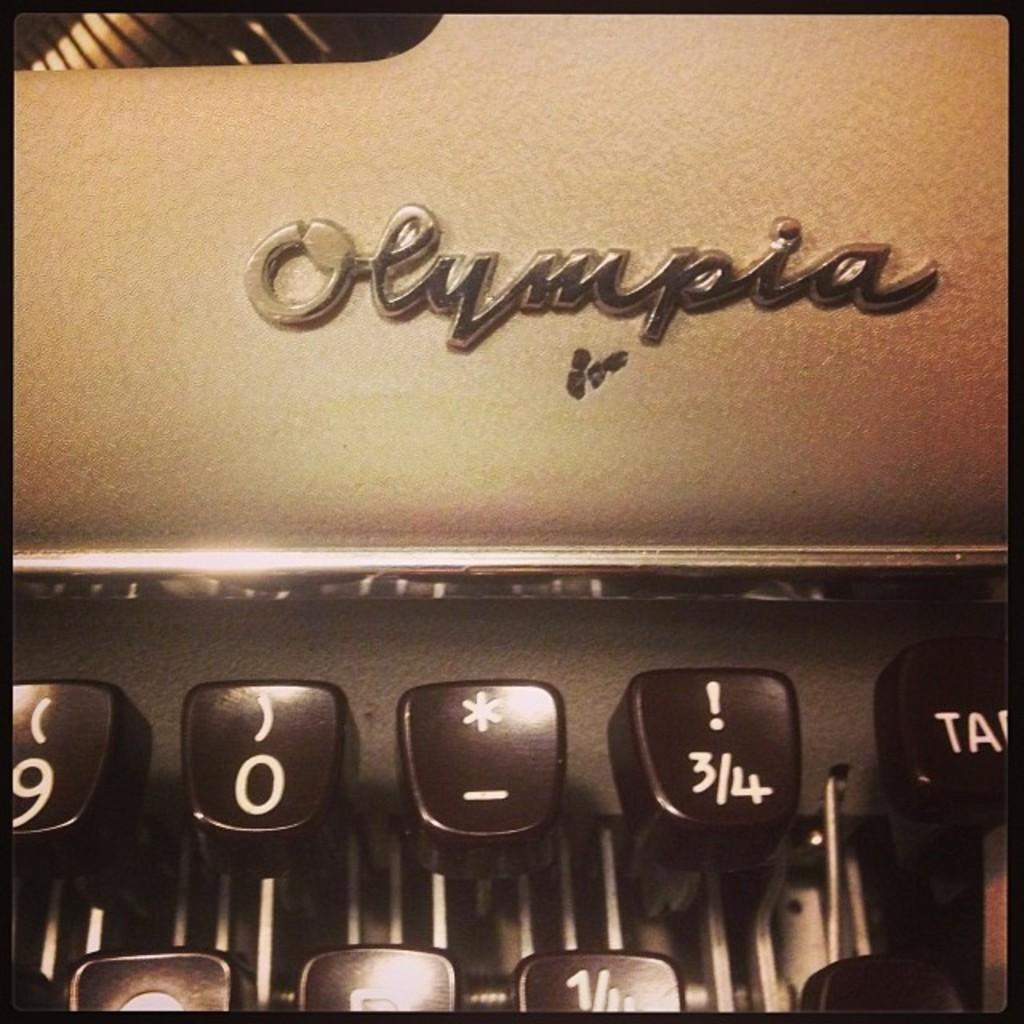<image>
Relay a brief, clear account of the picture shown. An old typewriter that shows upclose the brand Olympia logo 